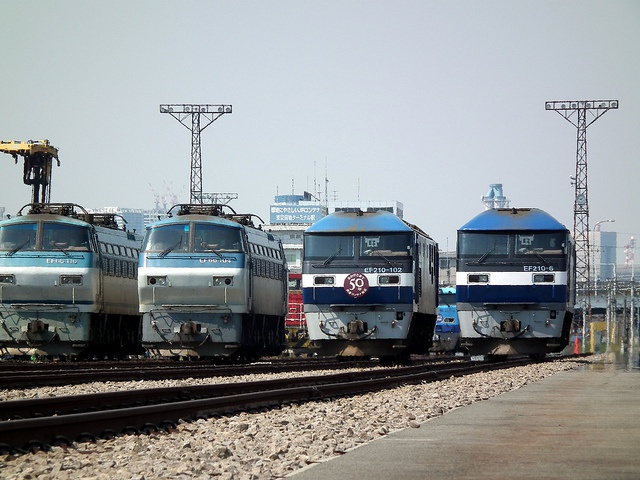Describe the objects in this image and their specific colors. I can see train in lightgray, gray, black, darkgray, and blue tones, train in lightgray, black, gray, navy, and darkgray tones, train in lightgray, black, gray, and blue tones, and train in lightgray, black, gray, blue, and navy tones in this image. 